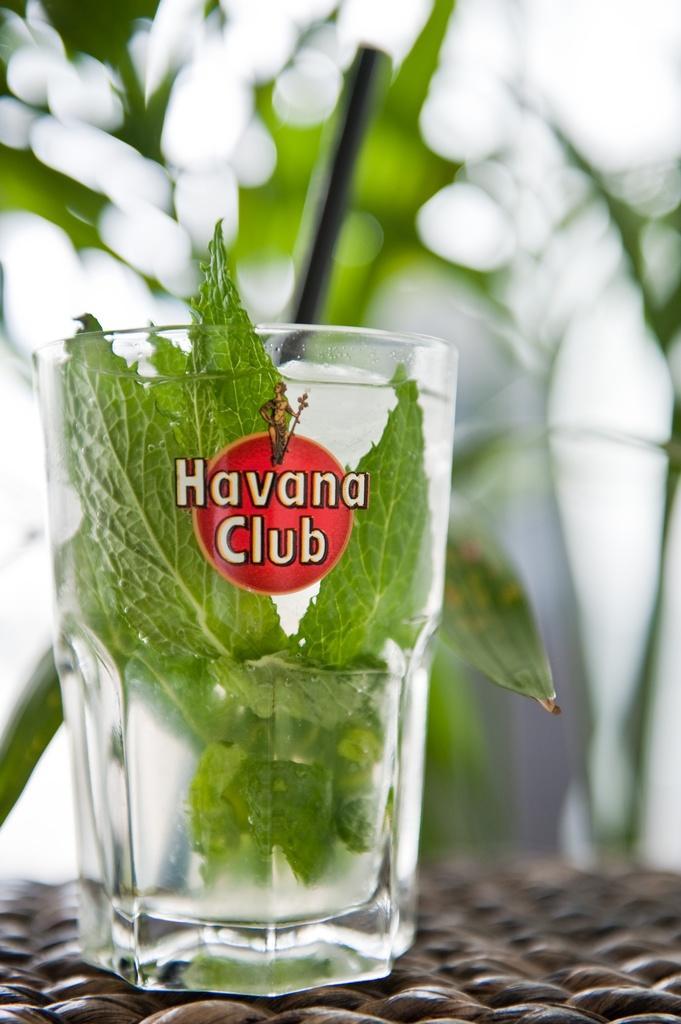Can you describe this image briefly? In this picture we can see a glass placed on a platform with water and leaves in it and in the background we can see trees and it is blurry. 